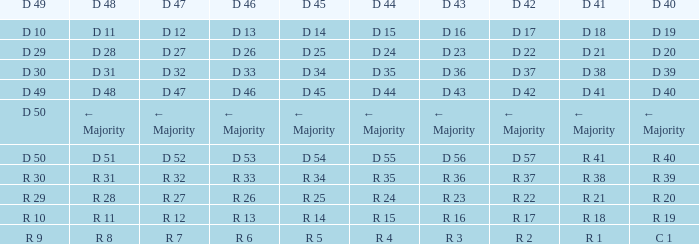Tell me the D 49 and D 46 of r 13 R 10. 